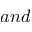Convert formula to latex. <formula><loc_0><loc_0><loc_500><loc_500>a n d</formula> 